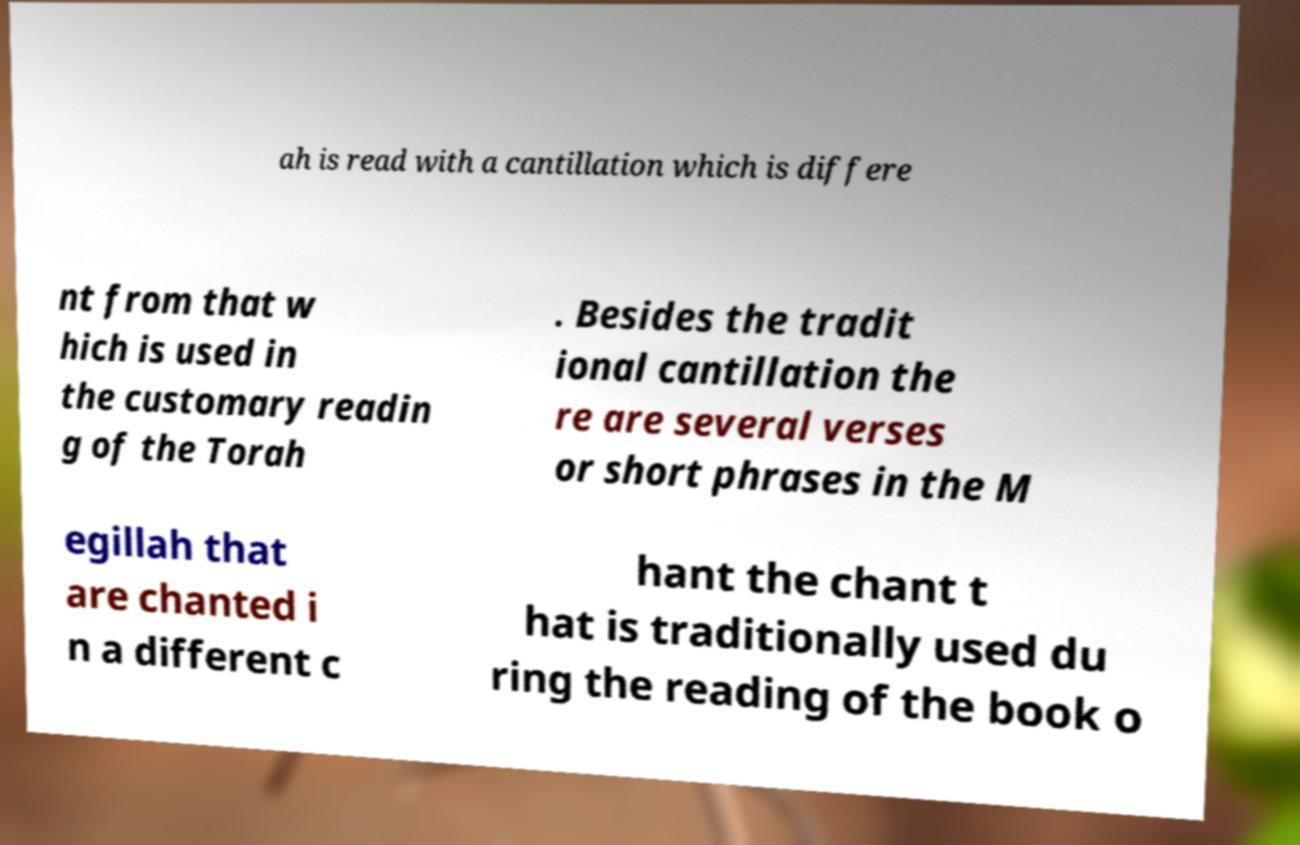Could you assist in decoding the text presented in this image and type it out clearly? ah is read with a cantillation which is differe nt from that w hich is used in the customary readin g of the Torah . Besides the tradit ional cantillation the re are several verses or short phrases in the M egillah that are chanted i n a different c hant the chant t hat is traditionally used du ring the reading of the book o 